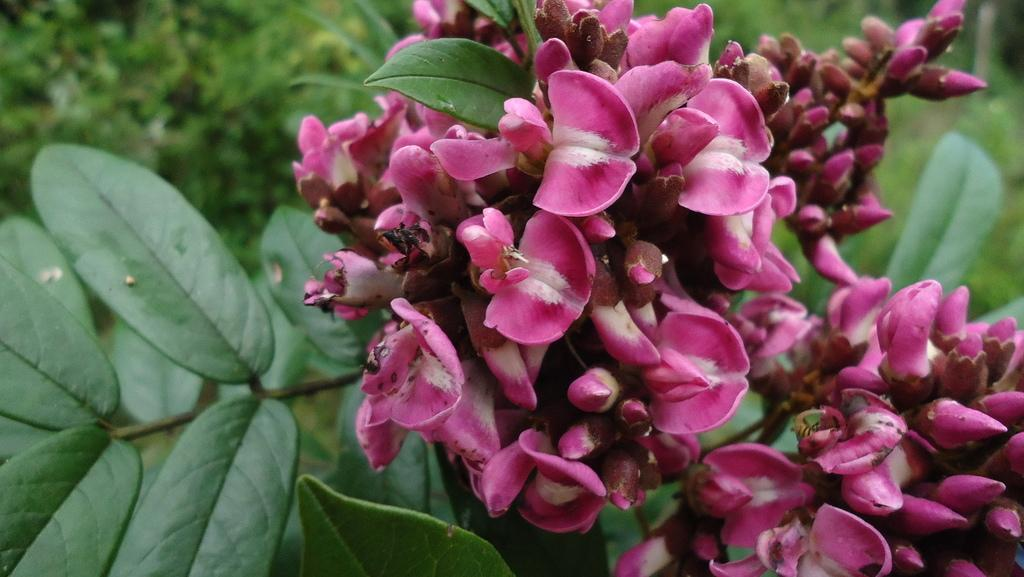What type of living organisms can be seen in the image? Flowers and plants can be seen in the image. Can you describe the background of the image? The background of the image is blurred. What type of hat is the flower wearing in the image? There is no hat present in the image, as the main subjects are flowers and plants. What is the reaction of the plants to the chance of rain? There is no indication of rain or any reaction from the plants in the image. 